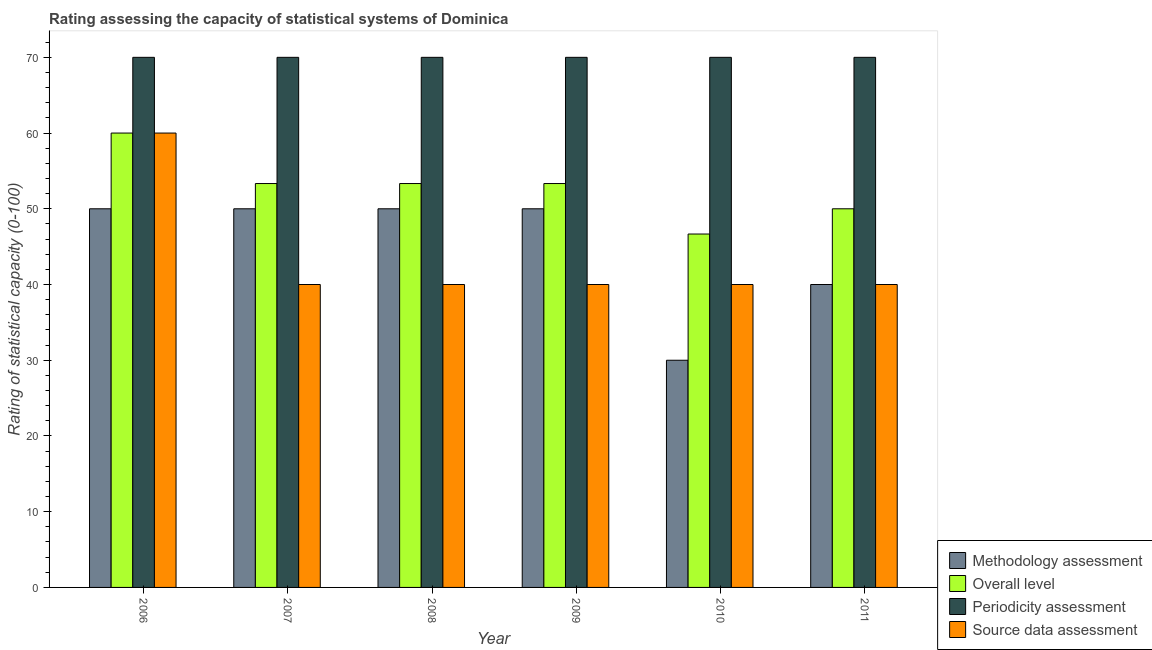How many bars are there on the 3rd tick from the left?
Ensure brevity in your answer.  4. In how many cases, is the number of bars for a given year not equal to the number of legend labels?
Offer a terse response. 0. What is the methodology assessment rating in 2008?
Your answer should be very brief. 50. Across all years, what is the maximum periodicity assessment rating?
Offer a terse response. 70. Across all years, what is the minimum methodology assessment rating?
Your answer should be very brief. 30. What is the total overall level rating in the graph?
Provide a short and direct response. 316.67. What is the difference between the source data assessment rating in 2011 and the methodology assessment rating in 2006?
Offer a very short reply. -20. What is the average overall level rating per year?
Your answer should be compact. 52.78. In how many years, is the periodicity assessment rating greater than 38?
Provide a short and direct response. 6. What is the ratio of the source data assessment rating in 2010 to that in 2011?
Make the answer very short. 1. What is the difference between the highest and the second highest overall level rating?
Provide a succinct answer. 6.67. What is the difference between the highest and the lowest methodology assessment rating?
Make the answer very short. 20. Is the sum of the overall level rating in 2009 and 2011 greater than the maximum methodology assessment rating across all years?
Make the answer very short. Yes. What does the 2nd bar from the left in 2006 represents?
Provide a short and direct response. Overall level. What does the 2nd bar from the right in 2010 represents?
Your answer should be compact. Periodicity assessment. Is it the case that in every year, the sum of the methodology assessment rating and overall level rating is greater than the periodicity assessment rating?
Provide a short and direct response. Yes. How many bars are there?
Ensure brevity in your answer.  24. How many years are there in the graph?
Your answer should be compact. 6. What is the difference between two consecutive major ticks on the Y-axis?
Make the answer very short. 10. Does the graph contain any zero values?
Keep it short and to the point. No. Where does the legend appear in the graph?
Your answer should be very brief. Bottom right. How many legend labels are there?
Provide a short and direct response. 4. What is the title of the graph?
Your response must be concise. Rating assessing the capacity of statistical systems of Dominica. Does "Insurance services" appear as one of the legend labels in the graph?
Offer a very short reply. No. What is the label or title of the X-axis?
Offer a very short reply. Year. What is the label or title of the Y-axis?
Keep it short and to the point. Rating of statistical capacity (0-100). What is the Rating of statistical capacity (0-100) of Methodology assessment in 2006?
Make the answer very short. 50. What is the Rating of statistical capacity (0-100) of Overall level in 2006?
Keep it short and to the point. 60. What is the Rating of statistical capacity (0-100) in Overall level in 2007?
Your answer should be compact. 53.33. What is the Rating of statistical capacity (0-100) of Source data assessment in 2007?
Provide a succinct answer. 40. What is the Rating of statistical capacity (0-100) in Methodology assessment in 2008?
Ensure brevity in your answer.  50. What is the Rating of statistical capacity (0-100) of Overall level in 2008?
Offer a terse response. 53.33. What is the Rating of statistical capacity (0-100) in Source data assessment in 2008?
Ensure brevity in your answer.  40. What is the Rating of statistical capacity (0-100) of Methodology assessment in 2009?
Make the answer very short. 50. What is the Rating of statistical capacity (0-100) in Overall level in 2009?
Offer a terse response. 53.33. What is the Rating of statistical capacity (0-100) of Source data assessment in 2009?
Provide a short and direct response. 40. What is the Rating of statistical capacity (0-100) in Methodology assessment in 2010?
Give a very brief answer. 30. What is the Rating of statistical capacity (0-100) in Overall level in 2010?
Offer a very short reply. 46.67. What is the Rating of statistical capacity (0-100) in Source data assessment in 2010?
Give a very brief answer. 40. What is the Rating of statistical capacity (0-100) in Methodology assessment in 2011?
Ensure brevity in your answer.  40. What is the Rating of statistical capacity (0-100) of Overall level in 2011?
Offer a very short reply. 50. What is the Rating of statistical capacity (0-100) of Periodicity assessment in 2011?
Keep it short and to the point. 70. What is the Rating of statistical capacity (0-100) of Source data assessment in 2011?
Make the answer very short. 40. Across all years, what is the maximum Rating of statistical capacity (0-100) in Overall level?
Offer a very short reply. 60. Across all years, what is the maximum Rating of statistical capacity (0-100) in Source data assessment?
Your answer should be compact. 60. Across all years, what is the minimum Rating of statistical capacity (0-100) of Methodology assessment?
Your answer should be very brief. 30. Across all years, what is the minimum Rating of statistical capacity (0-100) in Overall level?
Your answer should be compact. 46.67. Across all years, what is the minimum Rating of statistical capacity (0-100) of Source data assessment?
Provide a succinct answer. 40. What is the total Rating of statistical capacity (0-100) in Methodology assessment in the graph?
Make the answer very short. 270. What is the total Rating of statistical capacity (0-100) of Overall level in the graph?
Your response must be concise. 316.67. What is the total Rating of statistical capacity (0-100) in Periodicity assessment in the graph?
Ensure brevity in your answer.  420. What is the total Rating of statistical capacity (0-100) in Source data assessment in the graph?
Your answer should be compact. 260. What is the difference between the Rating of statistical capacity (0-100) in Overall level in 2006 and that in 2007?
Keep it short and to the point. 6.67. What is the difference between the Rating of statistical capacity (0-100) of Periodicity assessment in 2006 and that in 2007?
Provide a short and direct response. 0. What is the difference between the Rating of statistical capacity (0-100) of Source data assessment in 2006 and that in 2007?
Your response must be concise. 20. What is the difference between the Rating of statistical capacity (0-100) of Overall level in 2006 and that in 2008?
Your answer should be compact. 6.67. What is the difference between the Rating of statistical capacity (0-100) in Periodicity assessment in 2006 and that in 2008?
Ensure brevity in your answer.  0. What is the difference between the Rating of statistical capacity (0-100) in Methodology assessment in 2006 and that in 2009?
Give a very brief answer. 0. What is the difference between the Rating of statistical capacity (0-100) of Overall level in 2006 and that in 2009?
Your response must be concise. 6.67. What is the difference between the Rating of statistical capacity (0-100) in Source data assessment in 2006 and that in 2009?
Provide a succinct answer. 20. What is the difference between the Rating of statistical capacity (0-100) of Overall level in 2006 and that in 2010?
Offer a very short reply. 13.33. What is the difference between the Rating of statistical capacity (0-100) of Periodicity assessment in 2006 and that in 2010?
Provide a succinct answer. 0. What is the difference between the Rating of statistical capacity (0-100) in Source data assessment in 2006 and that in 2010?
Your response must be concise. 20. What is the difference between the Rating of statistical capacity (0-100) in Methodology assessment in 2006 and that in 2011?
Offer a very short reply. 10. What is the difference between the Rating of statistical capacity (0-100) in Overall level in 2006 and that in 2011?
Ensure brevity in your answer.  10. What is the difference between the Rating of statistical capacity (0-100) in Periodicity assessment in 2006 and that in 2011?
Provide a short and direct response. 0. What is the difference between the Rating of statistical capacity (0-100) of Methodology assessment in 2007 and that in 2008?
Keep it short and to the point. 0. What is the difference between the Rating of statistical capacity (0-100) in Overall level in 2007 and that in 2008?
Your answer should be very brief. 0. What is the difference between the Rating of statistical capacity (0-100) of Source data assessment in 2007 and that in 2008?
Keep it short and to the point. 0. What is the difference between the Rating of statistical capacity (0-100) in Periodicity assessment in 2007 and that in 2009?
Ensure brevity in your answer.  0. What is the difference between the Rating of statistical capacity (0-100) in Methodology assessment in 2007 and that in 2010?
Give a very brief answer. 20. What is the difference between the Rating of statistical capacity (0-100) of Overall level in 2007 and that in 2010?
Offer a very short reply. 6.67. What is the difference between the Rating of statistical capacity (0-100) in Periodicity assessment in 2007 and that in 2010?
Keep it short and to the point. 0. What is the difference between the Rating of statistical capacity (0-100) in Methodology assessment in 2007 and that in 2011?
Give a very brief answer. 10. What is the difference between the Rating of statistical capacity (0-100) in Overall level in 2007 and that in 2011?
Your answer should be compact. 3.33. What is the difference between the Rating of statistical capacity (0-100) in Methodology assessment in 2008 and that in 2009?
Provide a succinct answer. 0. What is the difference between the Rating of statistical capacity (0-100) of Overall level in 2008 and that in 2009?
Ensure brevity in your answer.  0. What is the difference between the Rating of statistical capacity (0-100) of Periodicity assessment in 2008 and that in 2009?
Your answer should be compact. 0. What is the difference between the Rating of statistical capacity (0-100) in Source data assessment in 2008 and that in 2009?
Your answer should be very brief. 0. What is the difference between the Rating of statistical capacity (0-100) in Overall level in 2008 and that in 2010?
Make the answer very short. 6.67. What is the difference between the Rating of statistical capacity (0-100) of Methodology assessment in 2008 and that in 2011?
Give a very brief answer. 10. What is the difference between the Rating of statistical capacity (0-100) of Overall level in 2008 and that in 2011?
Offer a terse response. 3.33. What is the difference between the Rating of statistical capacity (0-100) in Periodicity assessment in 2008 and that in 2011?
Your response must be concise. 0. What is the difference between the Rating of statistical capacity (0-100) of Periodicity assessment in 2009 and that in 2010?
Provide a short and direct response. 0. What is the difference between the Rating of statistical capacity (0-100) in Source data assessment in 2009 and that in 2010?
Your answer should be very brief. 0. What is the difference between the Rating of statistical capacity (0-100) of Methodology assessment in 2009 and that in 2011?
Your response must be concise. 10. What is the difference between the Rating of statistical capacity (0-100) in Periodicity assessment in 2010 and that in 2011?
Offer a terse response. 0. What is the difference between the Rating of statistical capacity (0-100) of Source data assessment in 2010 and that in 2011?
Ensure brevity in your answer.  0. What is the difference between the Rating of statistical capacity (0-100) of Methodology assessment in 2006 and the Rating of statistical capacity (0-100) of Periodicity assessment in 2007?
Keep it short and to the point. -20. What is the difference between the Rating of statistical capacity (0-100) of Methodology assessment in 2006 and the Rating of statistical capacity (0-100) of Source data assessment in 2007?
Keep it short and to the point. 10. What is the difference between the Rating of statistical capacity (0-100) in Overall level in 2006 and the Rating of statistical capacity (0-100) in Source data assessment in 2007?
Keep it short and to the point. 20. What is the difference between the Rating of statistical capacity (0-100) in Methodology assessment in 2006 and the Rating of statistical capacity (0-100) in Overall level in 2008?
Make the answer very short. -3.33. What is the difference between the Rating of statistical capacity (0-100) of Methodology assessment in 2006 and the Rating of statistical capacity (0-100) of Periodicity assessment in 2008?
Provide a short and direct response. -20. What is the difference between the Rating of statistical capacity (0-100) in Methodology assessment in 2006 and the Rating of statistical capacity (0-100) in Source data assessment in 2008?
Offer a terse response. 10. What is the difference between the Rating of statistical capacity (0-100) in Methodology assessment in 2006 and the Rating of statistical capacity (0-100) in Periodicity assessment in 2009?
Ensure brevity in your answer.  -20. What is the difference between the Rating of statistical capacity (0-100) of Methodology assessment in 2006 and the Rating of statistical capacity (0-100) of Source data assessment in 2009?
Ensure brevity in your answer.  10. What is the difference between the Rating of statistical capacity (0-100) in Overall level in 2006 and the Rating of statistical capacity (0-100) in Periodicity assessment in 2009?
Provide a succinct answer. -10. What is the difference between the Rating of statistical capacity (0-100) of Methodology assessment in 2006 and the Rating of statistical capacity (0-100) of Overall level in 2010?
Offer a very short reply. 3.33. What is the difference between the Rating of statistical capacity (0-100) of Methodology assessment in 2006 and the Rating of statistical capacity (0-100) of Periodicity assessment in 2010?
Keep it short and to the point. -20. What is the difference between the Rating of statistical capacity (0-100) in Methodology assessment in 2006 and the Rating of statistical capacity (0-100) in Source data assessment in 2010?
Keep it short and to the point. 10. What is the difference between the Rating of statistical capacity (0-100) of Overall level in 2006 and the Rating of statistical capacity (0-100) of Periodicity assessment in 2010?
Your response must be concise. -10. What is the difference between the Rating of statistical capacity (0-100) in Overall level in 2006 and the Rating of statistical capacity (0-100) in Source data assessment in 2010?
Your response must be concise. 20. What is the difference between the Rating of statistical capacity (0-100) of Periodicity assessment in 2006 and the Rating of statistical capacity (0-100) of Source data assessment in 2010?
Your answer should be compact. 30. What is the difference between the Rating of statistical capacity (0-100) in Methodology assessment in 2006 and the Rating of statistical capacity (0-100) in Overall level in 2011?
Give a very brief answer. 0. What is the difference between the Rating of statistical capacity (0-100) of Methodology assessment in 2006 and the Rating of statistical capacity (0-100) of Periodicity assessment in 2011?
Keep it short and to the point. -20. What is the difference between the Rating of statistical capacity (0-100) in Methodology assessment in 2006 and the Rating of statistical capacity (0-100) in Source data assessment in 2011?
Your answer should be very brief. 10. What is the difference between the Rating of statistical capacity (0-100) in Overall level in 2006 and the Rating of statistical capacity (0-100) in Periodicity assessment in 2011?
Offer a very short reply. -10. What is the difference between the Rating of statistical capacity (0-100) in Overall level in 2006 and the Rating of statistical capacity (0-100) in Source data assessment in 2011?
Offer a terse response. 20. What is the difference between the Rating of statistical capacity (0-100) in Periodicity assessment in 2006 and the Rating of statistical capacity (0-100) in Source data assessment in 2011?
Your response must be concise. 30. What is the difference between the Rating of statistical capacity (0-100) of Methodology assessment in 2007 and the Rating of statistical capacity (0-100) of Overall level in 2008?
Your response must be concise. -3.33. What is the difference between the Rating of statistical capacity (0-100) of Methodology assessment in 2007 and the Rating of statistical capacity (0-100) of Periodicity assessment in 2008?
Give a very brief answer. -20. What is the difference between the Rating of statistical capacity (0-100) of Overall level in 2007 and the Rating of statistical capacity (0-100) of Periodicity assessment in 2008?
Your response must be concise. -16.67. What is the difference between the Rating of statistical capacity (0-100) of Overall level in 2007 and the Rating of statistical capacity (0-100) of Source data assessment in 2008?
Provide a short and direct response. 13.33. What is the difference between the Rating of statistical capacity (0-100) in Periodicity assessment in 2007 and the Rating of statistical capacity (0-100) in Source data assessment in 2008?
Your answer should be compact. 30. What is the difference between the Rating of statistical capacity (0-100) of Methodology assessment in 2007 and the Rating of statistical capacity (0-100) of Overall level in 2009?
Provide a succinct answer. -3.33. What is the difference between the Rating of statistical capacity (0-100) of Methodology assessment in 2007 and the Rating of statistical capacity (0-100) of Source data assessment in 2009?
Your answer should be compact. 10. What is the difference between the Rating of statistical capacity (0-100) of Overall level in 2007 and the Rating of statistical capacity (0-100) of Periodicity assessment in 2009?
Give a very brief answer. -16.67. What is the difference between the Rating of statistical capacity (0-100) of Overall level in 2007 and the Rating of statistical capacity (0-100) of Source data assessment in 2009?
Ensure brevity in your answer.  13.33. What is the difference between the Rating of statistical capacity (0-100) of Overall level in 2007 and the Rating of statistical capacity (0-100) of Periodicity assessment in 2010?
Offer a terse response. -16.67. What is the difference between the Rating of statistical capacity (0-100) of Overall level in 2007 and the Rating of statistical capacity (0-100) of Source data assessment in 2010?
Offer a terse response. 13.33. What is the difference between the Rating of statistical capacity (0-100) of Methodology assessment in 2007 and the Rating of statistical capacity (0-100) of Source data assessment in 2011?
Make the answer very short. 10. What is the difference between the Rating of statistical capacity (0-100) in Overall level in 2007 and the Rating of statistical capacity (0-100) in Periodicity assessment in 2011?
Keep it short and to the point. -16.67. What is the difference between the Rating of statistical capacity (0-100) in Overall level in 2007 and the Rating of statistical capacity (0-100) in Source data assessment in 2011?
Ensure brevity in your answer.  13.33. What is the difference between the Rating of statistical capacity (0-100) of Periodicity assessment in 2007 and the Rating of statistical capacity (0-100) of Source data assessment in 2011?
Offer a terse response. 30. What is the difference between the Rating of statistical capacity (0-100) of Methodology assessment in 2008 and the Rating of statistical capacity (0-100) of Periodicity assessment in 2009?
Make the answer very short. -20. What is the difference between the Rating of statistical capacity (0-100) of Methodology assessment in 2008 and the Rating of statistical capacity (0-100) of Source data assessment in 2009?
Keep it short and to the point. 10. What is the difference between the Rating of statistical capacity (0-100) in Overall level in 2008 and the Rating of statistical capacity (0-100) in Periodicity assessment in 2009?
Ensure brevity in your answer.  -16.67. What is the difference between the Rating of statistical capacity (0-100) of Overall level in 2008 and the Rating of statistical capacity (0-100) of Source data assessment in 2009?
Your answer should be very brief. 13.33. What is the difference between the Rating of statistical capacity (0-100) in Periodicity assessment in 2008 and the Rating of statistical capacity (0-100) in Source data assessment in 2009?
Your answer should be compact. 30. What is the difference between the Rating of statistical capacity (0-100) of Methodology assessment in 2008 and the Rating of statistical capacity (0-100) of Periodicity assessment in 2010?
Give a very brief answer. -20. What is the difference between the Rating of statistical capacity (0-100) of Overall level in 2008 and the Rating of statistical capacity (0-100) of Periodicity assessment in 2010?
Give a very brief answer. -16.67. What is the difference between the Rating of statistical capacity (0-100) in Overall level in 2008 and the Rating of statistical capacity (0-100) in Source data assessment in 2010?
Your answer should be compact. 13.33. What is the difference between the Rating of statistical capacity (0-100) of Methodology assessment in 2008 and the Rating of statistical capacity (0-100) of Source data assessment in 2011?
Your answer should be compact. 10. What is the difference between the Rating of statistical capacity (0-100) of Overall level in 2008 and the Rating of statistical capacity (0-100) of Periodicity assessment in 2011?
Provide a short and direct response. -16.67. What is the difference between the Rating of statistical capacity (0-100) of Overall level in 2008 and the Rating of statistical capacity (0-100) of Source data assessment in 2011?
Your answer should be compact. 13.33. What is the difference between the Rating of statistical capacity (0-100) in Methodology assessment in 2009 and the Rating of statistical capacity (0-100) in Periodicity assessment in 2010?
Your answer should be very brief. -20. What is the difference between the Rating of statistical capacity (0-100) of Methodology assessment in 2009 and the Rating of statistical capacity (0-100) of Source data assessment in 2010?
Provide a succinct answer. 10. What is the difference between the Rating of statistical capacity (0-100) of Overall level in 2009 and the Rating of statistical capacity (0-100) of Periodicity assessment in 2010?
Your response must be concise. -16.67. What is the difference between the Rating of statistical capacity (0-100) in Overall level in 2009 and the Rating of statistical capacity (0-100) in Source data assessment in 2010?
Ensure brevity in your answer.  13.33. What is the difference between the Rating of statistical capacity (0-100) of Methodology assessment in 2009 and the Rating of statistical capacity (0-100) of Periodicity assessment in 2011?
Provide a succinct answer. -20. What is the difference between the Rating of statistical capacity (0-100) in Methodology assessment in 2009 and the Rating of statistical capacity (0-100) in Source data assessment in 2011?
Ensure brevity in your answer.  10. What is the difference between the Rating of statistical capacity (0-100) of Overall level in 2009 and the Rating of statistical capacity (0-100) of Periodicity assessment in 2011?
Provide a short and direct response. -16.67. What is the difference between the Rating of statistical capacity (0-100) in Overall level in 2009 and the Rating of statistical capacity (0-100) in Source data assessment in 2011?
Make the answer very short. 13.33. What is the difference between the Rating of statistical capacity (0-100) of Periodicity assessment in 2009 and the Rating of statistical capacity (0-100) of Source data assessment in 2011?
Your answer should be very brief. 30. What is the difference between the Rating of statistical capacity (0-100) of Methodology assessment in 2010 and the Rating of statistical capacity (0-100) of Periodicity assessment in 2011?
Provide a succinct answer. -40. What is the difference between the Rating of statistical capacity (0-100) in Methodology assessment in 2010 and the Rating of statistical capacity (0-100) in Source data assessment in 2011?
Give a very brief answer. -10. What is the difference between the Rating of statistical capacity (0-100) in Overall level in 2010 and the Rating of statistical capacity (0-100) in Periodicity assessment in 2011?
Keep it short and to the point. -23.33. What is the difference between the Rating of statistical capacity (0-100) of Periodicity assessment in 2010 and the Rating of statistical capacity (0-100) of Source data assessment in 2011?
Ensure brevity in your answer.  30. What is the average Rating of statistical capacity (0-100) in Overall level per year?
Your answer should be compact. 52.78. What is the average Rating of statistical capacity (0-100) of Periodicity assessment per year?
Your answer should be compact. 70. What is the average Rating of statistical capacity (0-100) of Source data assessment per year?
Your response must be concise. 43.33. In the year 2006, what is the difference between the Rating of statistical capacity (0-100) in Periodicity assessment and Rating of statistical capacity (0-100) in Source data assessment?
Your answer should be very brief. 10. In the year 2007, what is the difference between the Rating of statistical capacity (0-100) in Methodology assessment and Rating of statistical capacity (0-100) in Periodicity assessment?
Keep it short and to the point. -20. In the year 2007, what is the difference between the Rating of statistical capacity (0-100) of Overall level and Rating of statistical capacity (0-100) of Periodicity assessment?
Make the answer very short. -16.67. In the year 2007, what is the difference between the Rating of statistical capacity (0-100) of Overall level and Rating of statistical capacity (0-100) of Source data assessment?
Your answer should be very brief. 13.33. In the year 2007, what is the difference between the Rating of statistical capacity (0-100) in Periodicity assessment and Rating of statistical capacity (0-100) in Source data assessment?
Keep it short and to the point. 30. In the year 2008, what is the difference between the Rating of statistical capacity (0-100) of Methodology assessment and Rating of statistical capacity (0-100) of Overall level?
Offer a terse response. -3.33. In the year 2008, what is the difference between the Rating of statistical capacity (0-100) of Overall level and Rating of statistical capacity (0-100) of Periodicity assessment?
Provide a short and direct response. -16.67. In the year 2008, what is the difference between the Rating of statistical capacity (0-100) of Overall level and Rating of statistical capacity (0-100) of Source data assessment?
Your response must be concise. 13.33. In the year 2008, what is the difference between the Rating of statistical capacity (0-100) in Periodicity assessment and Rating of statistical capacity (0-100) in Source data assessment?
Make the answer very short. 30. In the year 2009, what is the difference between the Rating of statistical capacity (0-100) of Methodology assessment and Rating of statistical capacity (0-100) of Overall level?
Offer a terse response. -3.33. In the year 2009, what is the difference between the Rating of statistical capacity (0-100) in Methodology assessment and Rating of statistical capacity (0-100) in Periodicity assessment?
Keep it short and to the point. -20. In the year 2009, what is the difference between the Rating of statistical capacity (0-100) of Overall level and Rating of statistical capacity (0-100) of Periodicity assessment?
Keep it short and to the point. -16.67. In the year 2009, what is the difference between the Rating of statistical capacity (0-100) of Overall level and Rating of statistical capacity (0-100) of Source data assessment?
Make the answer very short. 13.33. In the year 2010, what is the difference between the Rating of statistical capacity (0-100) in Methodology assessment and Rating of statistical capacity (0-100) in Overall level?
Provide a short and direct response. -16.67. In the year 2010, what is the difference between the Rating of statistical capacity (0-100) of Methodology assessment and Rating of statistical capacity (0-100) of Source data assessment?
Keep it short and to the point. -10. In the year 2010, what is the difference between the Rating of statistical capacity (0-100) in Overall level and Rating of statistical capacity (0-100) in Periodicity assessment?
Your answer should be very brief. -23.33. In the year 2010, what is the difference between the Rating of statistical capacity (0-100) in Overall level and Rating of statistical capacity (0-100) in Source data assessment?
Offer a very short reply. 6.67. In the year 2011, what is the difference between the Rating of statistical capacity (0-100) in Methodology assessment and Rating of statistical capacity (0-100) in Periodicity assessment?
Your answer should be compact. -30. In the year 2011, what is the difference between the Rating of statistical capacity (0-100) of Methodology assessment and Rating of statistical capacity (0-100) of Source data assessment?
Offer a terse response. 0. In the year 2011, what is the difference between the Rating of statistical capacity (0-100) in Overall level and Rating of statistical capacity (0-100) in Periodicity assessment?
Your answer should be very brief. -20. In the year 2011, what is the difference between the Rating of statistical capacity (0-100) of Overall level and Rating of statistical capacity (0-100) of Source data assessment?
Keep it short and to the point. 10. What is the ratio of the Rating of statistical capacity (0-100) in Overall level in 2006 to that in 2007?
Ensure brevity in your answer.  1.12. What is the ratio of the Rating of statistical capacity (0-100) in Methodology assessment in 2006 to that in 2008?
Your answer should be very brief. 1. What is the ratio of the Rating of statistical capacity (0-100) of Periodicity assessment in 2006 to that in 2008?
Your answer should be compact. 1. What is the ratio of the Rating of statistical capacity (0-100) in Source data assessment in 2006 to that in 2008?
Give a very brief answer. 1.5. What is the ratio of the Rating of statistical capacity (0-100) in Overall level in 2006 to that in 2009?
Make the answer very short. 1.12. What is the ratio of the Rating of statistical capacity (0-100) of Periodicity assessment in 2006 to that in 2009?
Offer a terse response. 1. What is the ratio of the Rating of statistical capacity (0-100) in Overall level in 2006 to that in 2010?
Provide a succinct answer. 1.29. What is the ratio of the Rating of statistical capacity (0-100) of Periodicity assessment in 2006 to that in 2010?
Your answer should be compact. 1. What is the ratio of the Rating of statistical capacity (0-100) in Source data assessment in 2006 to that in 2010?
Offer a very short reply. 1.5. What is the ratio of the Rating of statistical capacity (0-100) in Overall level in 2006 to that in 2011?
Offer a very short reply. 1.2. What is the ratio of the Rating of statistical capacity (0-100) of Source data assessment in 2006 to that in 2011?
Ensure brevity in your answer.  1.5. What is the ratio of the Rating of statistical capacity (0-100) in Methodology assessment in 2007 to that in 2008?
Keep it short and to the point. 1. What is the ratio of the Rating of statistical capacity (0-100) in Source data assessment in 2007 to that in 2008?
Offer a very short reply. 1. What is the ratio of the Rating of statistical capacity (0-100) in Overall level in 2007 to that in 2009?
Make the answer very short. 1. What is the ratio of the Rating of statistical capacity (0-100) of Source data assessment in 2007 to that in 2009?
Provide a short and direct response. 1. What is the ratio of the Rating of statistical capacity (0-100) in Methodology assessment in 2007 to that in 2010?
Your response must be concise. 1.67. What is the ratio of the Rating of statistical capacity (0-100) in Overall level in 2007 to that in 2010?
Give a very brief answer. 1.14. What is the ratio of the Rating of statistical capacity (0-100) in Periodicity assessment in 2007 to that in 2010?
Offer a very short reply. 1. What is the ratio of the Rating of statistical capacity (0-100) in Source data assessment in 2007 to that in 2010?
Provide a succinct answer. 1. What is the ratio of the Rating of statistical capacity (0-100) of Methodology assessment in 2007 to that in 2011?
Provide a succinct answer. 1.25. What is the ratio of the Rating of statistical capacity (0-100) in Overall level in 2007 to that in 2011?
Offer a terse response. 1.07. What is the ratio of the Rating of statistical capacity (0-100) of Periodicity assessment in 2007 to that in 2011?
Ensure brevity in your answer.  1. What is the ratio of the Rating of statistical capacity (0-100) of Source data assessment in 2007 to that in 2011?
Give a very brief answer. 1. What is the ratio of the Rating of statistical capacity (0-100) in Methodology assessment in 2008 to that in 2009?
Provide a succinct answer. 1. What is the ratio of the Rating of statistical capacity (0-100) in Overall level in 2008 to that in 2009?
Offer a very short reply. 1. What is the ratio of the Rating of statistical capacity (0-100) of Periodicity assessment in 2008 to that in 2009?
Your response must be concise. 1. What is the ratio of the Rating of statistical capacity (0-100) of Source data assessment in 2008 to that in 2009?
Provide a succinct answer. 1. What is the ratio of the Rating of statistical capacity (0-100) of Methodology assessment in 2008 to that in 2010?
Give a very brief answer. 1.67. What is the ratio of the Rating of statistical capacity (0-100) of Overall level in 2008 to that in 2010?
Your answer should be very brief. 1.14. What is the ratio of the Rating of statistical capacity (0-100) in Methodology assessment in 2008 to that in 2011?
Make the answer very short. 1.25. What is the ratio of the Rating of statistical capacity (0-100) of Overall level in 2008 to that in 2011?
Provide a short and direct response. 1.07. What is the ratio of the Rating of statistical capacity (0-100) of Periodicity assessment in 2008 to that in 2011?
Ensure brevity in your answer.  1. What is the ratio of the Rating of statistical capacity (0-100) of Source data assessment in 2008 to that in 2011?
Your answer should be very brief. 1. What is the ratio of the Rating of statistical capacity (0-100) of Periodicity assessment in 2009 to that in 2010?
Your response must be concise. 1. What is the ratio of the Rating of statistical capacity (0-100) of Overall level in 2009 to that in 2011?
Keep it short and to the point. 1.07. What is the ratio of the Rating of statistical capacity (0-100) of Source data assessment in 2010 to that in 2011?
Your response must be concise. 1. What is the difference between the highest and the second highest Rating of statistical capacity (0-100) of Methodology assessment?
Ensure brevity in your answer.  0. What is the difference between the highest and the lowest Rating of statistical capacity (0-100) of Methodology assessment?
Your response must be concise. 20. What is the difference between the highest and the lowest Rating of statistical capacity (0-100) of Overall level?
Ensure brevity in your answer.  13.33. What is the difference between the highest and the lowest Rating of statistical capacity (0-100) in Source data assessment?
Your response must be concise. 20. 